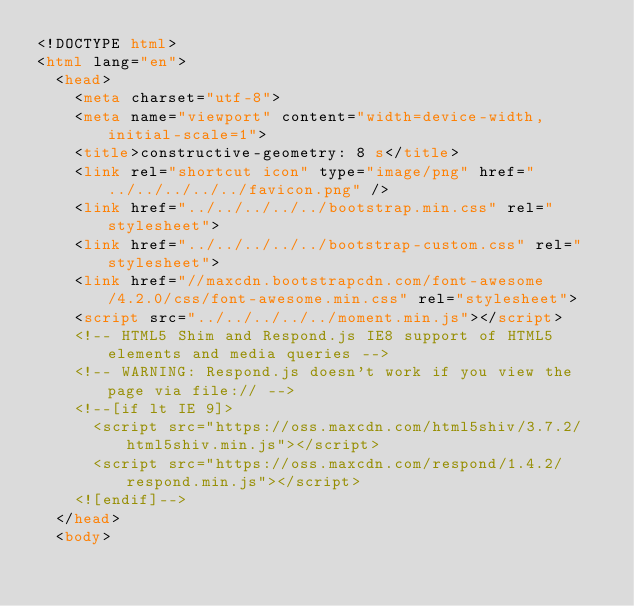<code> <loc_0><loc_0><loc_500><loc_500><_HTML_><!DOCTYPE html>
<html lang="en">
  <head>
    <meta charset="utf-8">
    <meta name="viewport" content="width=device-width, initial-scale=1">
    <title>constructive-geometry: 8 s</title>
    <link rel="shortcut icon" type="image/png" href="../../../../../favicon.png" />
    <link href="../../../../../bootstrap.min.css" rel="stylesheet">
    <link href="../../../../../bootstrap-custom.css" rel="stylesheet">
    <link href="//maxcdn.bootstrapcdn.com/font-awesome/4.2.0/css/font-awesome.min.css" rel="stylesheet">
    <script src="../../../../../moment.min.js"></script>
    <!-- HTML5 Shim and Respond.js IE8 support of HTML5 elements and media queries -->
    <!-- WARNING: Respond.js doesn't work if you view the page via file:// -->
    <!--[if lt IE 9]>
      <script src="https://oss.maxcdn.com/html5shiv/3.7.2/html5shiv.min.js"></script>
      <script src="https://oss.maxcdn.com/respond/1.4.2/respond.min.js"></script>
    <![endif]-->
  </head>
  <body></code> 